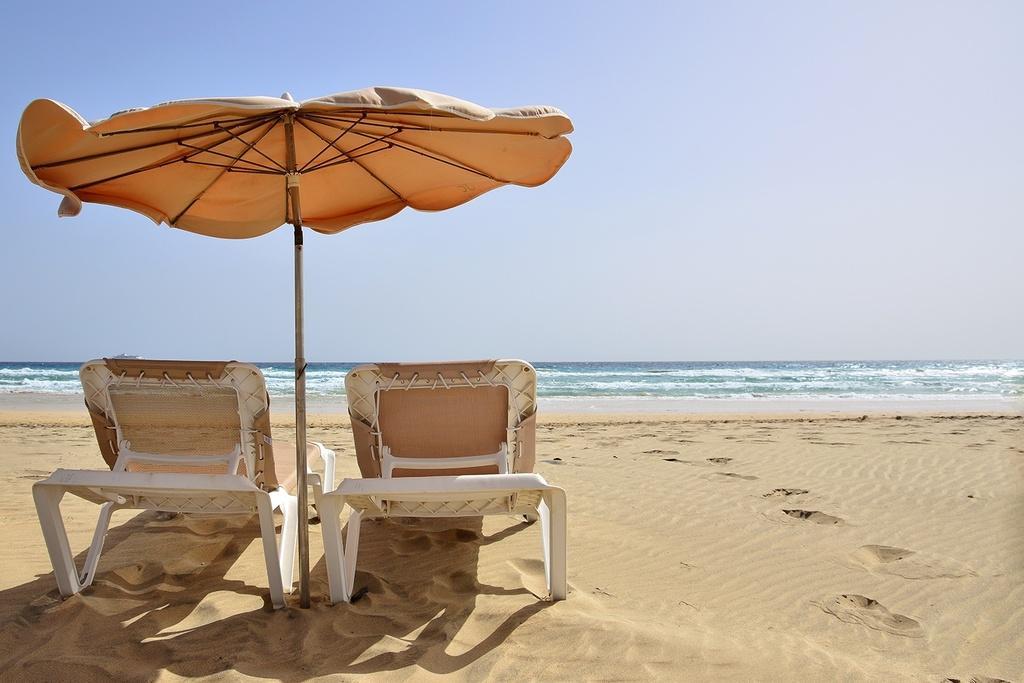Please provide a concise description of this image. In this image two chairs and an umbrella are on the land. Middle of the image there is water having some tides. Top of the image there is sky. 